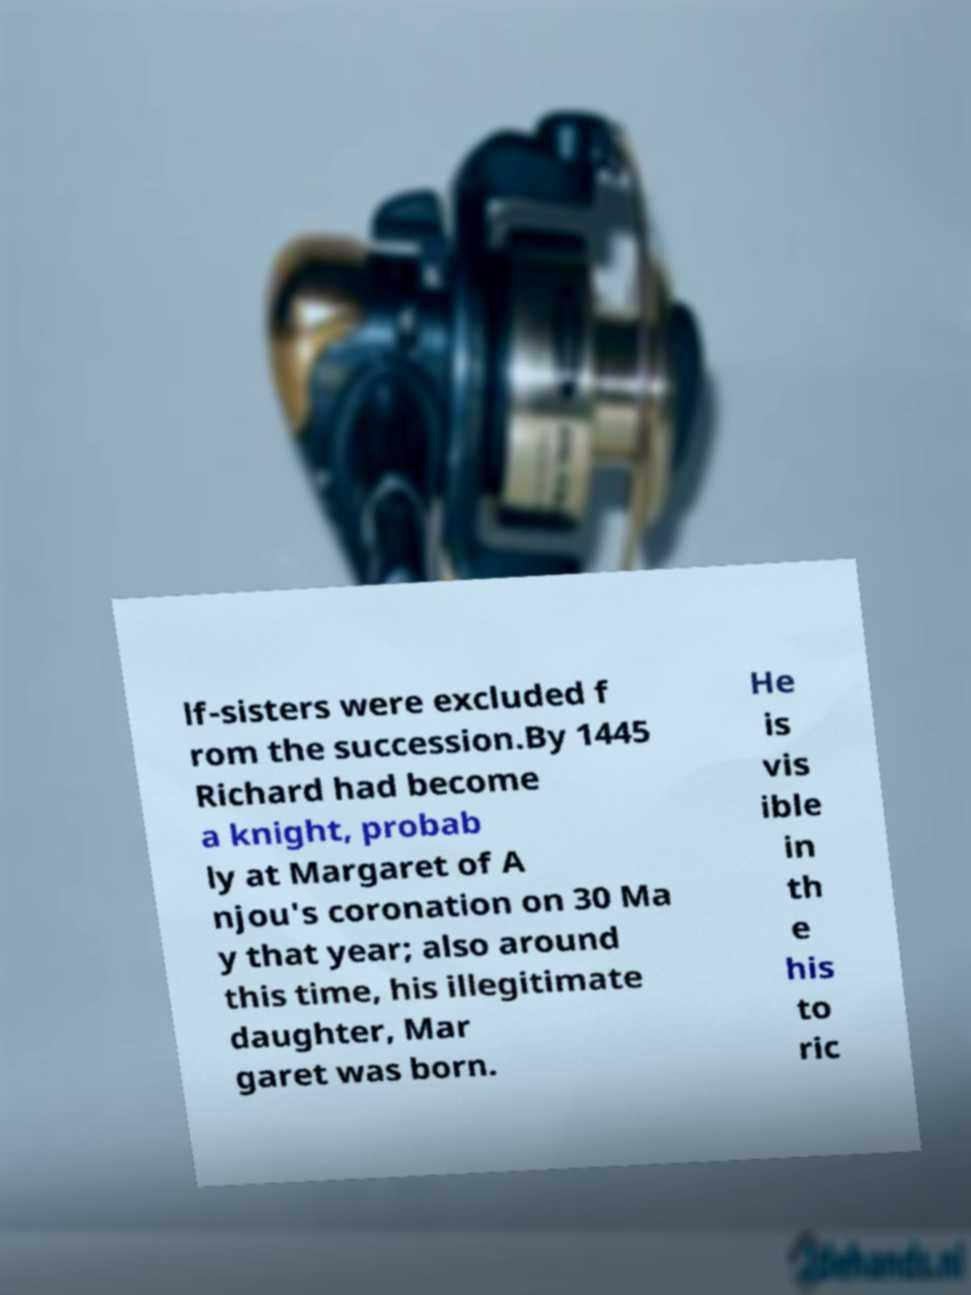Could you assist in decoding the text presented in this image and type it out clearly? lf-sisters were excluded f rom the succession.By 1445 Richard had become a knight, probab ly at Margaret of A njou's coronation on 30 Ma y that year; also around this time, his illegitimate daughter, Mar garet was born. He is vis ible in th e his to ric 